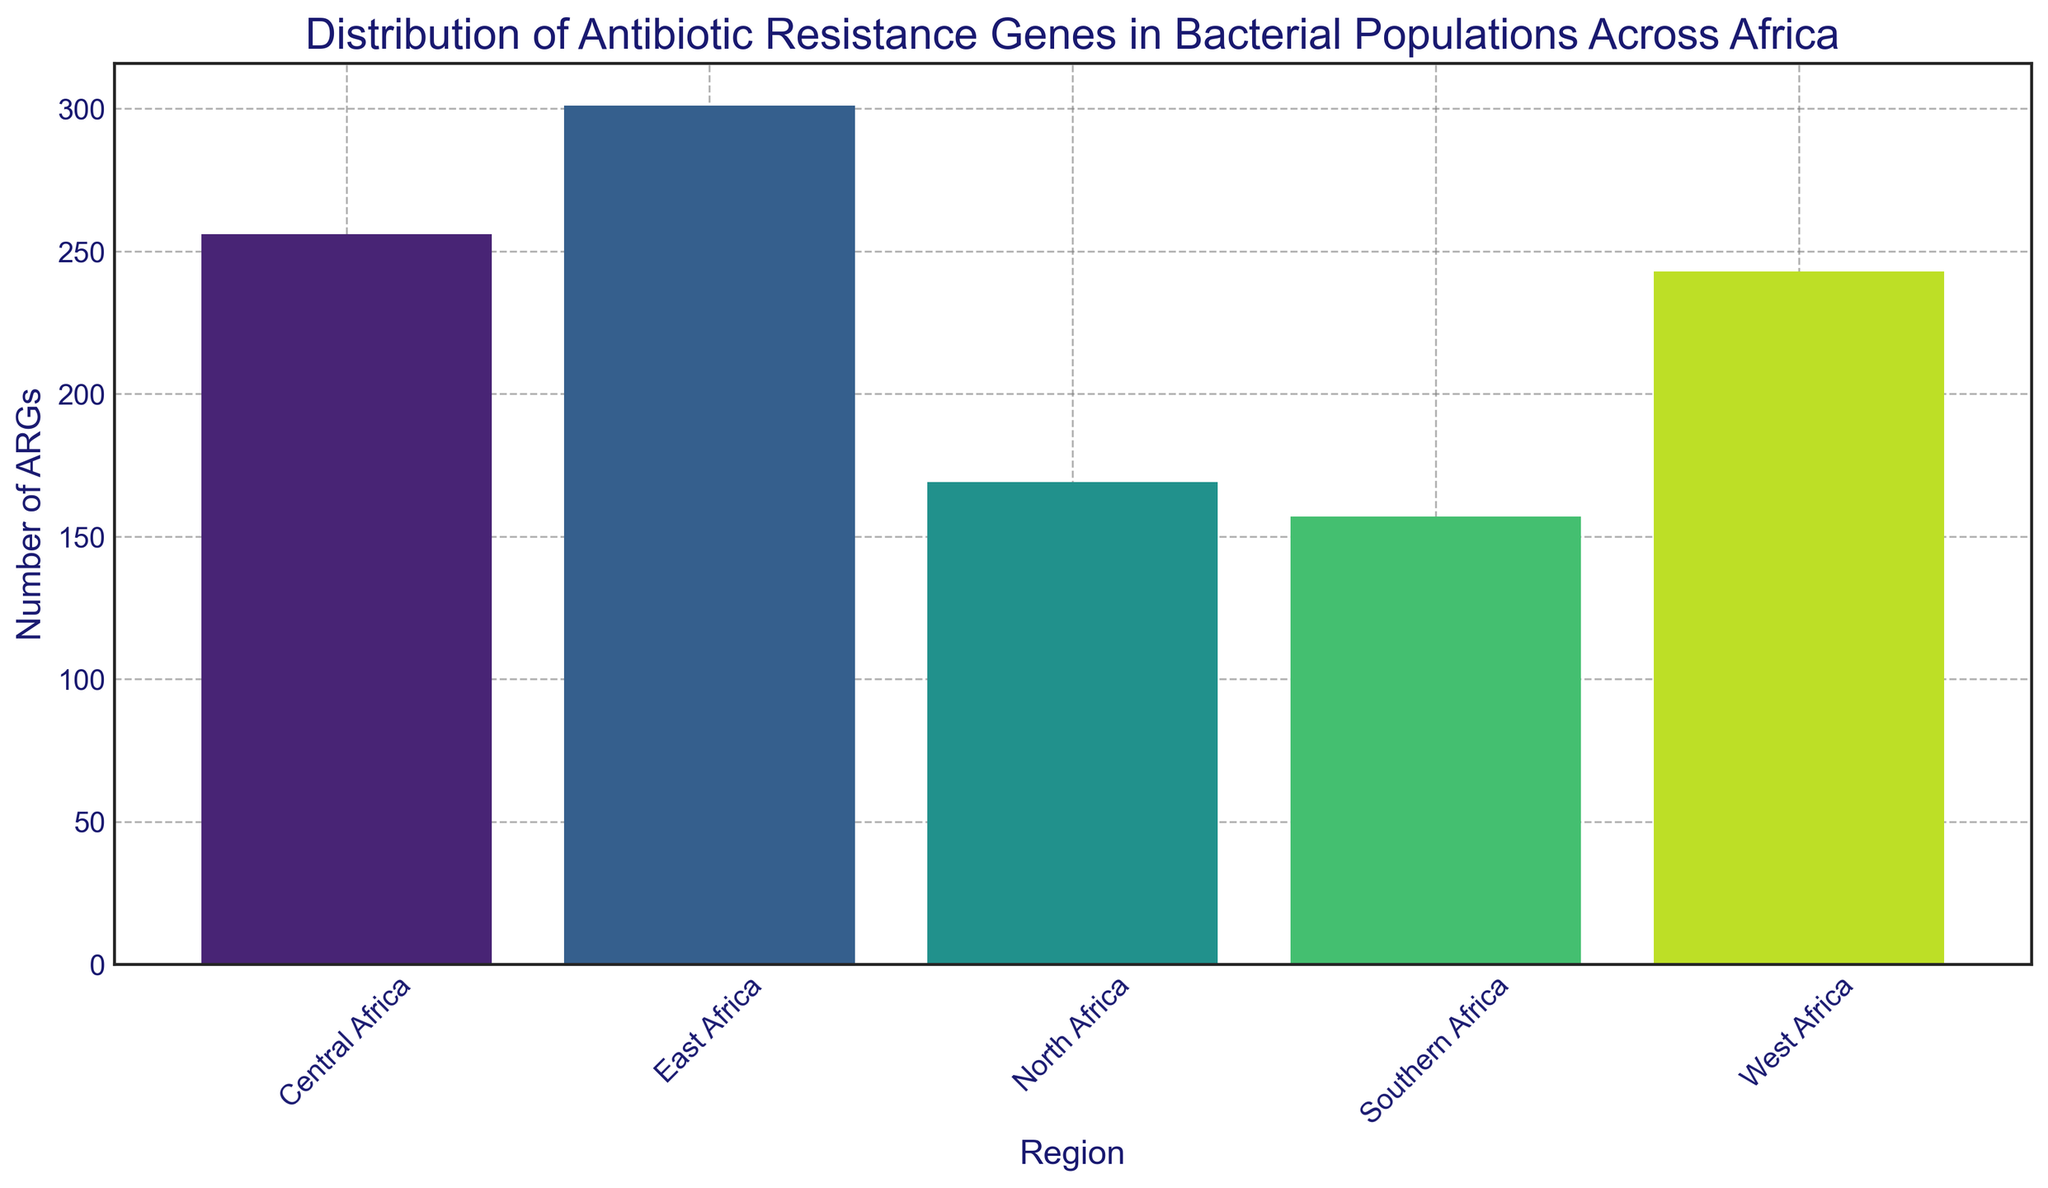What is the total number of antibiotic resistance genes (ARGs) in East Africa? To find the total number of ARGs in East Africa, sum up the values corresponding to East Africa. From the data: 56 + 63 + 59 + 58 + 65 = 301.
Answer: 301 Which region has the highest number of ARGs? By observing the heights of the bars, the East Africa bar is the tallest, indicating it has the highest number of ARGs.
Answer: East Africa What is the difference in the number of ARGs between East Africa and Southern Africa? First, sum the number of ARGs in East Africa: 56 + 63 + 59 + 58 + 65 = 301. Then sum those in Southern Africa: 29 + 34 + 31 + 30 + 33 = 157. The difference is 301 - 157 = 144.
Answer: 144 Which two regions have the closest number of ARGs? By examining the bars, North Africa and Central Africa appear to have the closest values. Summing them gives: North Africa = 34 + 39 + 28 + 32 + 36 = 169, Central Africa = 48 + 51 + 53 + 50 + 54 = 256. Subtracting results in: 256 - 169 = 87, whereas other region differences are larger.
Answer: North Africa and Central Africa What is the average number of ARGs in West Africa? Sum the number of ARGs in West Africa and then divide by the number of data points: 42 + 55 + 49 + 47 + 50 = 243. The average is 243/5 = 48.6.
Answer: 48.6 Which region has more ARGs: North Africa or Southern Africa? Summing the numbers: North Africa = 34 + 39 + 28 + 32 + 36 = 169, Southern Africa = 29 + 34 + 31 + 30 + 33 = 157. Comparing the sums: 169 > 157.
Answer: North Africa Is the bar for Central Africa taller or shorter than that for West Africa? By observing the heights, the Central Africa bar is taller than the West Africa bar.
Answer: Taller What is the ratio of the number of ARGs in East Africa to that in West Africa? Summing the ARGs, East Africa = 301, West Africa = 243. The ratio is 301 / 243 ≈ 1.24.
Answer: 1.24 